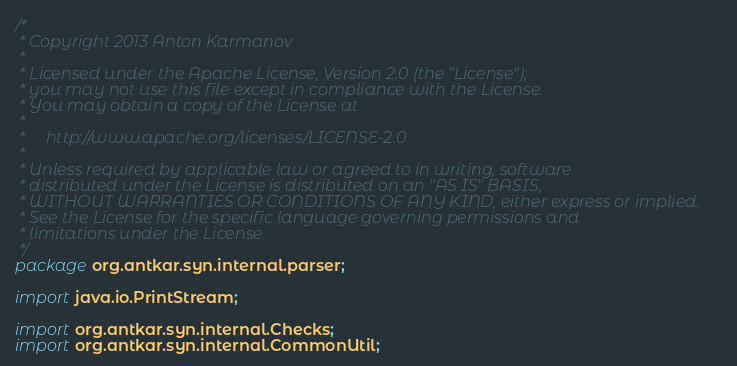Convert code to text. <code><loc_0><loc_0><loc_500><loc_500><_Java_>/*
 * Copyright 2013 Anton Karmanov
 *
 * Licensed under the Apache License, Version 2.0 (the "License");
 * you may not use this file except in compliance with the License.
 * You may obtain a copy of the License at
 *
 *     http://www.apache.org/licenses/LICENSE-2.0
 *
 * Unless required by applicable law or agreed to in writing, software
 * distributed under the License is distributed on an "AS IS" BASIS,
 * WITHOUT WARRANTIES OR CONDITIONS OF ANY KIND, either express or implied.
 * See the License for the specific language governing permissions and
 * limitations under the License.
 */
package org.antkar.syn.internal.parser;

import java.io.PrintStream;

import org.antkar.syn.internal.Checks;
import org.antkar.syn.internal.CommonUtil;</code> 